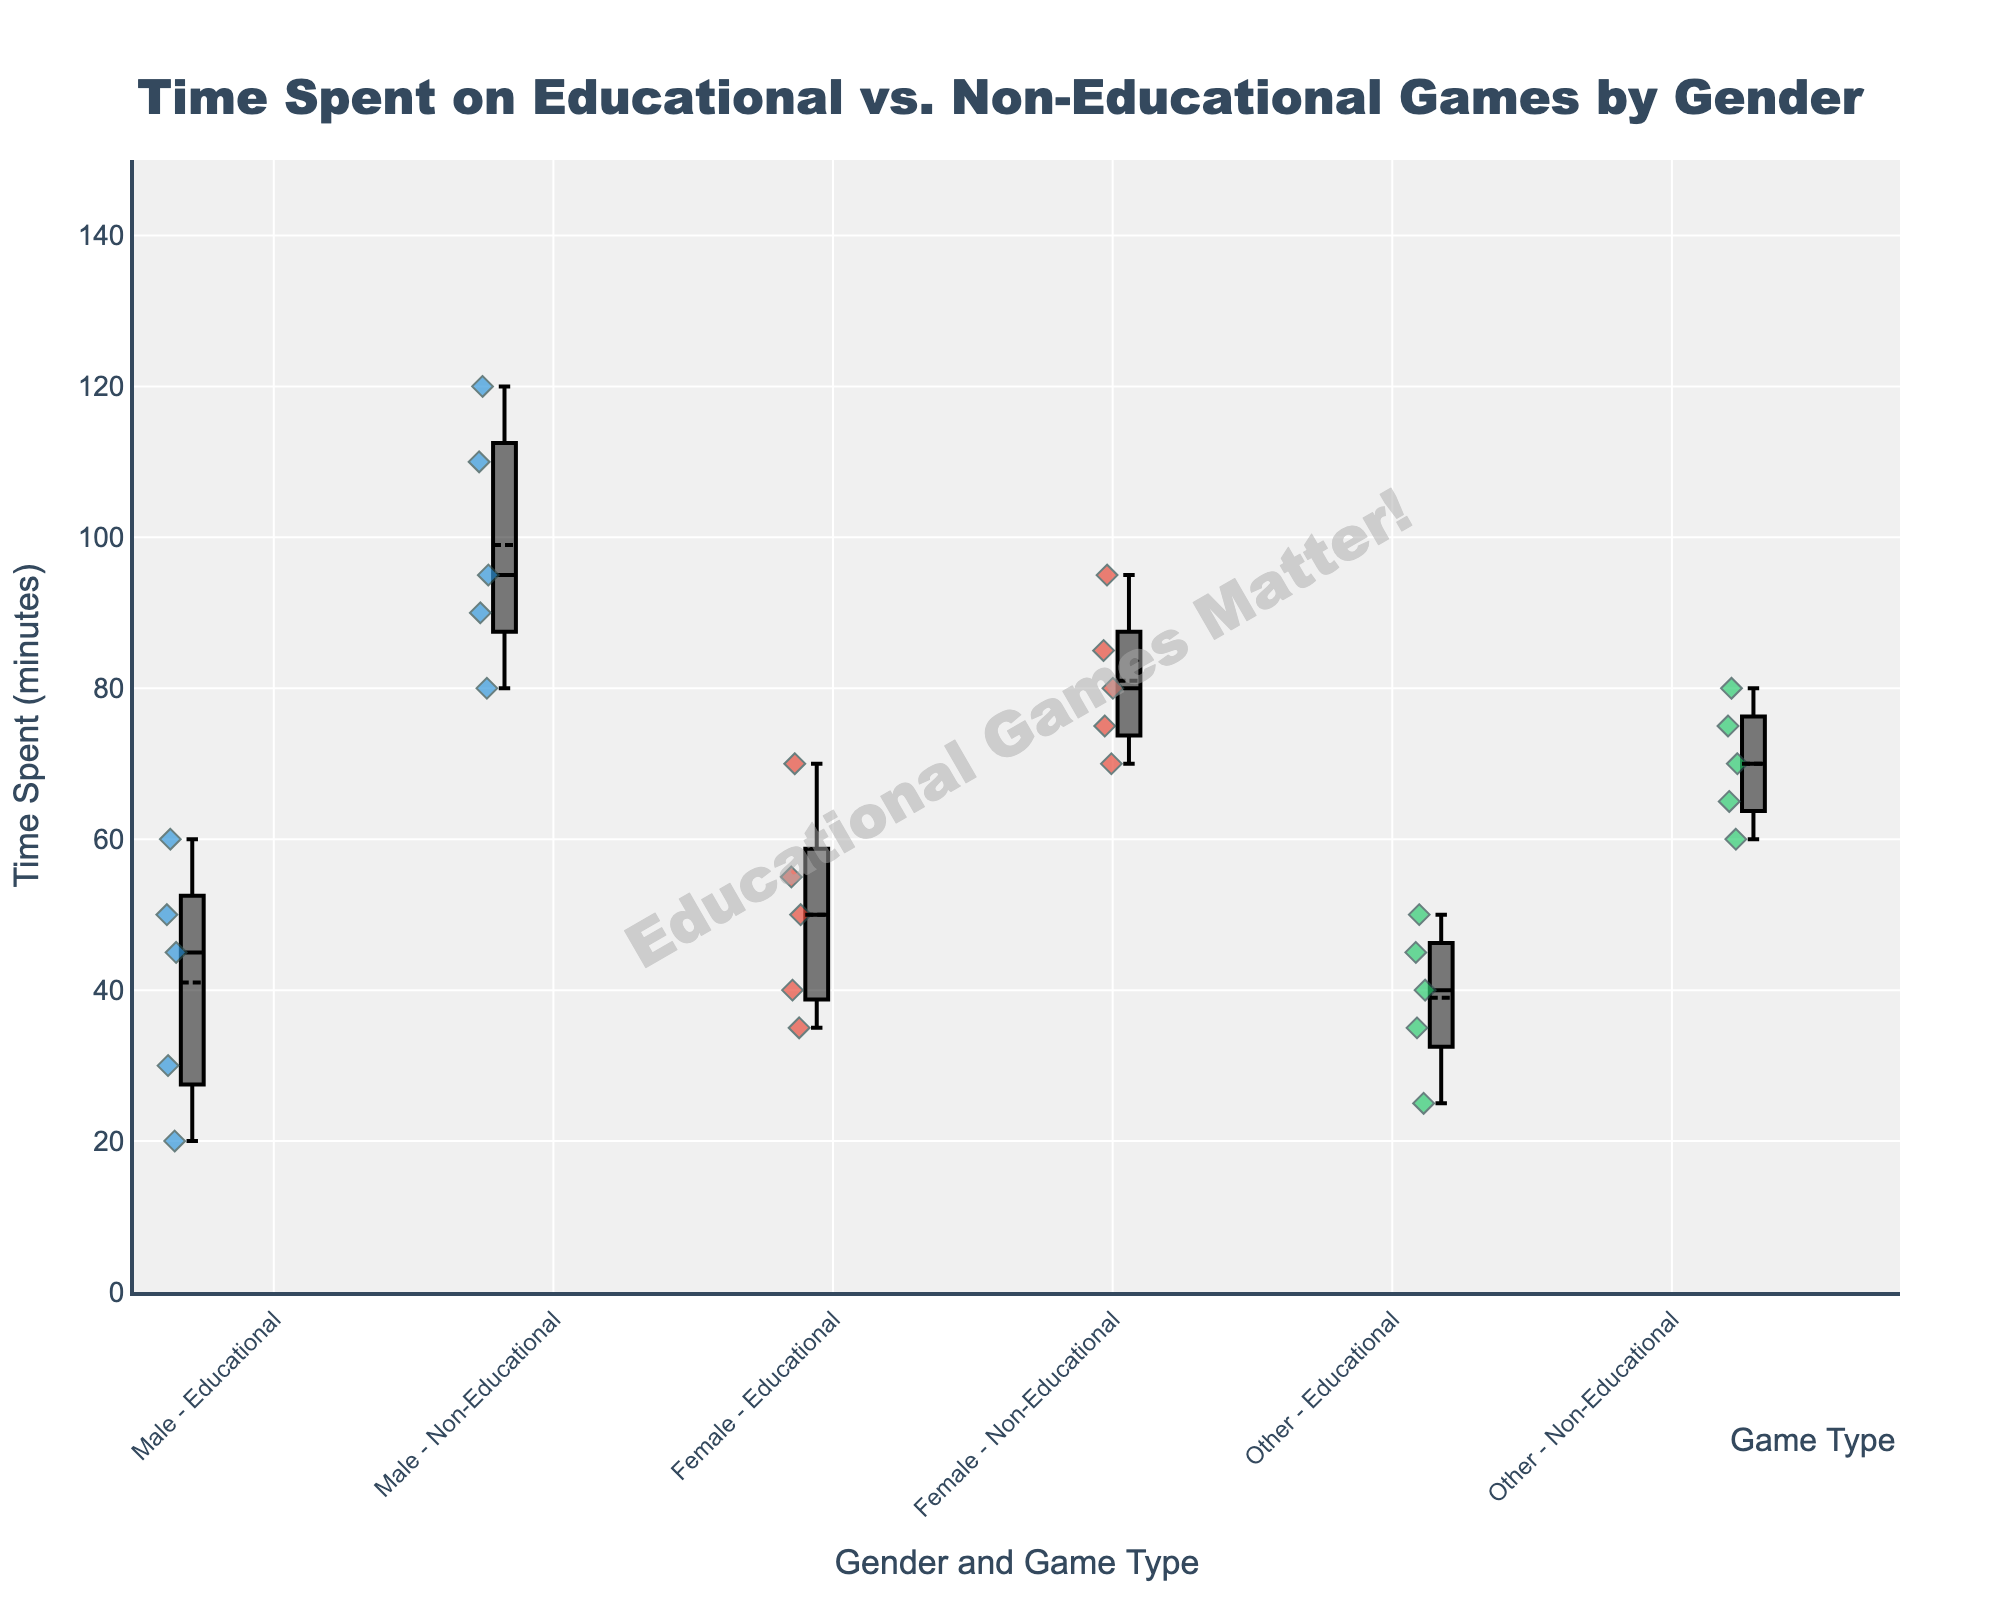What is the title of the figure? The title of the figure is usually located at the top and summarizes what the plot represents. In this case, it reads "Time Spent on Educational vs. Non-Educational Games by Gender."
Answer: Time Spent on Educational vs. Non-Educational Games by Gender What are the labels on the x-axis and y-axis? The x-axis label shows what categories are being compared and the y-axis label indicates the measure of these categories. Here, the x-axis is labeled "Gender and Game Type," and the y-axis is labeled "Time Spent (minutes)."
Answer: Gender and Game Type; Time Spent (minutes) How is the time spent on educational games different between males and females? To answer this, compare the median and interquartile range (IQR) of the boxes that represent males and females for educational games. The female's median is higher, and their IQR is broader compared to males.
Answer: Females spend more time on educational games than males Which gender spends the most time on non-educational games on average? Each box plot has a line indicating the mean. By comparing the means of non-educational games across genders, we see that males have the highest average time spent.
Answer: Males What is the median time spent by the "Other" gender on educational games? The median of a box plot is represented by the line inside the box. For "Other" gender on educational games, the median line is at 40 minutes.
Answer: 40 minutes Which group has the smallest range in time spent on non-educational games? The range can be observed by the length of the box and whiskers. "Other" gender shows the smallest range for non-educational games.
Answer: Other Compare the variance in time spent on educational games between genders. Variance can be inferred from the spread of the whiskers and the box. Males show a smaller spread compared to the other genders, indicating less variance.
Answer: Males have the least variance Is there a gender that spends more time overall (educational + non-educational)? Overall time can be compared by considering the means of educational and non-educational categories together. Males appear to spend more time overall.
Answer: Males Identify one outlier in the time spent on games by any gender and game type. Outliers in box plots are marked as points outside the whiskers. One visible outlier is a male spending 60 minutes on educational games.
Answer: Male, 60 minutes (Educational Games) What is the range of time spent by females on non-educational games? The range is calculated as the difference between the maximum and the minimum values. For females in non-educational games, the minimum is about 70 and the maximum is about 95, thus the range is 25 minutes.
Answer: 25 minutes 